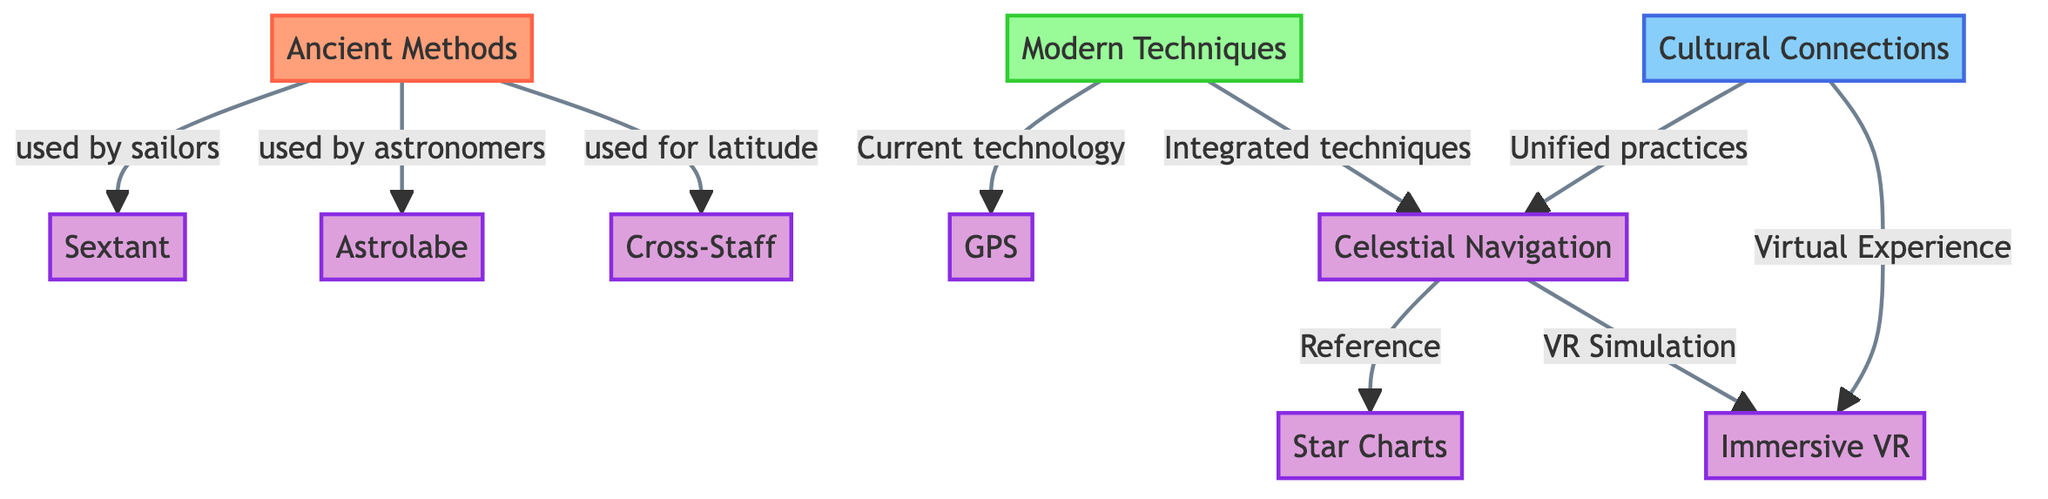What are the ancient methods of celestial navigation? The diagram indicates that the ancient methods include the sextant, astrolabe, and cross-staff. Each of these techniques is connected to the node "Ancient Methods."
Answer: sextant, astrolabe, cross-staff Which modern navigation technique is mentioned? According to the diagram, the modern techniques include GPS and celestial navigation. These are linked to the "Modern Techniques" node.
Answer: GPS, celestial navigation How many ancient navigation techniques are depicted in the diagram? The diagram shows three ancient navigation techniques (sextant, astrolabe, cross-staff) branching out from the "Ancient Methods" node.
Answer: 3 What is the relationship between celestial navigation and cultural connections? The diagram illustrates that celestial navigation has a direct connection to cultural connections, indicating that it unifies practices. This relationship is explicitly stated in the diagram.
Answer: Unified practices Which modern application of celestial navigation utilizes VR? The diagram highlights "Immersive VR" as a modern application of celestial navigation that is related to VR simulation. It's directly connected to the celestial navigation node.
Answer: Immersive VR What two components are associated with the cultural connections in the diagram? The diagram associates cultural connections with unified practices in celestial navigation and virtual experience through immersive VR. Both items are connected to the cultural connections node.
Answer: Unified practices, Virtual Experience How does celestial navigation reference traditional navigation aids? According to the diagram, celestial navigation is connected to star charts, illustrating that it references traditional navigation aids to provide guidance. This linkage indicates reliance on historical navigation tools.
Answer: star charts What technique is primarily used by astronomers in ancient navigation? The diagram indicates that the astrolabe is the technique primarily used by astronomers, as it is directly linked to the "Ancient Methods" node under the context of astronomers.
Answer: astrolabe 